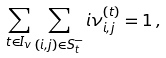Convert formula to latex. <formula><loc_0><loc_0><loc_500><loc_500>\sum _ { t \in I _ { v } } \sum _ { ( i , j ) \in S _ { t } ^ { - } } i \nu ^ { ( t ) } _ { i , j } = 1 \, ,</formula> 